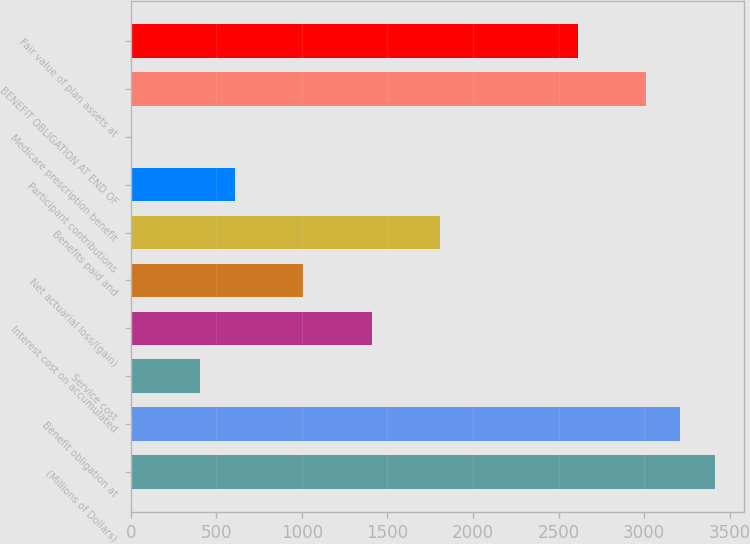<chart> <loc_0><loc_0><loc_500><loc_500><bar_chart><fcel>(Millions of Dollars)<fcel>Benefit obligation at<fcel>Service cost<fcel>Interest cost on accumulated<fcel>Net actuarial loss/(gain)<fcel>Benefits paid and<fcel>Participant contributions<fcel>Medicare prescription benefit<fcel>BENEFIT OBLIGATION AT END OF<fcel>Fair value of plan assets at<nl><fcel>3412.1<fcel>3211.8<fcel>407.6<fcel>1409.1<fcel>1008.5<fcel>1809.7<fcel>607.9<fcel>7<fcel>3011.5<fcel>2610.9<nl></chart> 